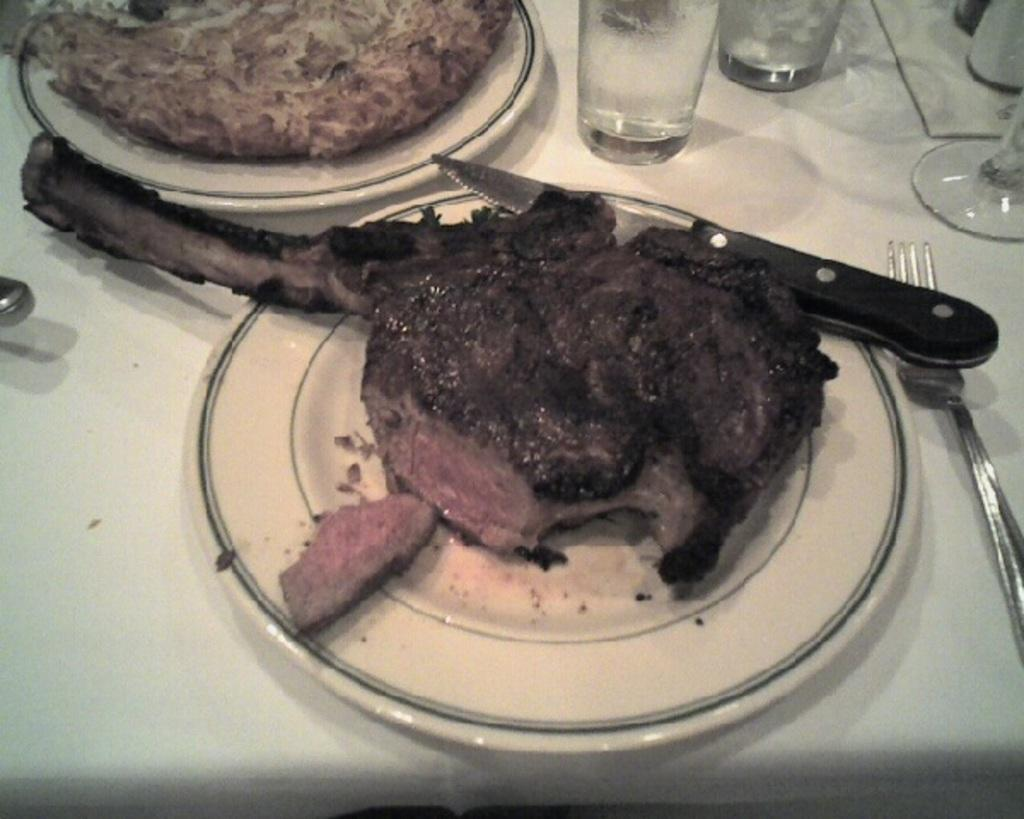What piece of furniture is present in the image? There is a table in the image. What items can be seen on the table? There are glasses, forks, plates, food items, and knives on the table. What might be used for eating the food items on the plates? The forks and knives on the table can be used for eating the food items. What type of fruit is being weighed on the scale in the image? There is no scale or fruit present in the image. 